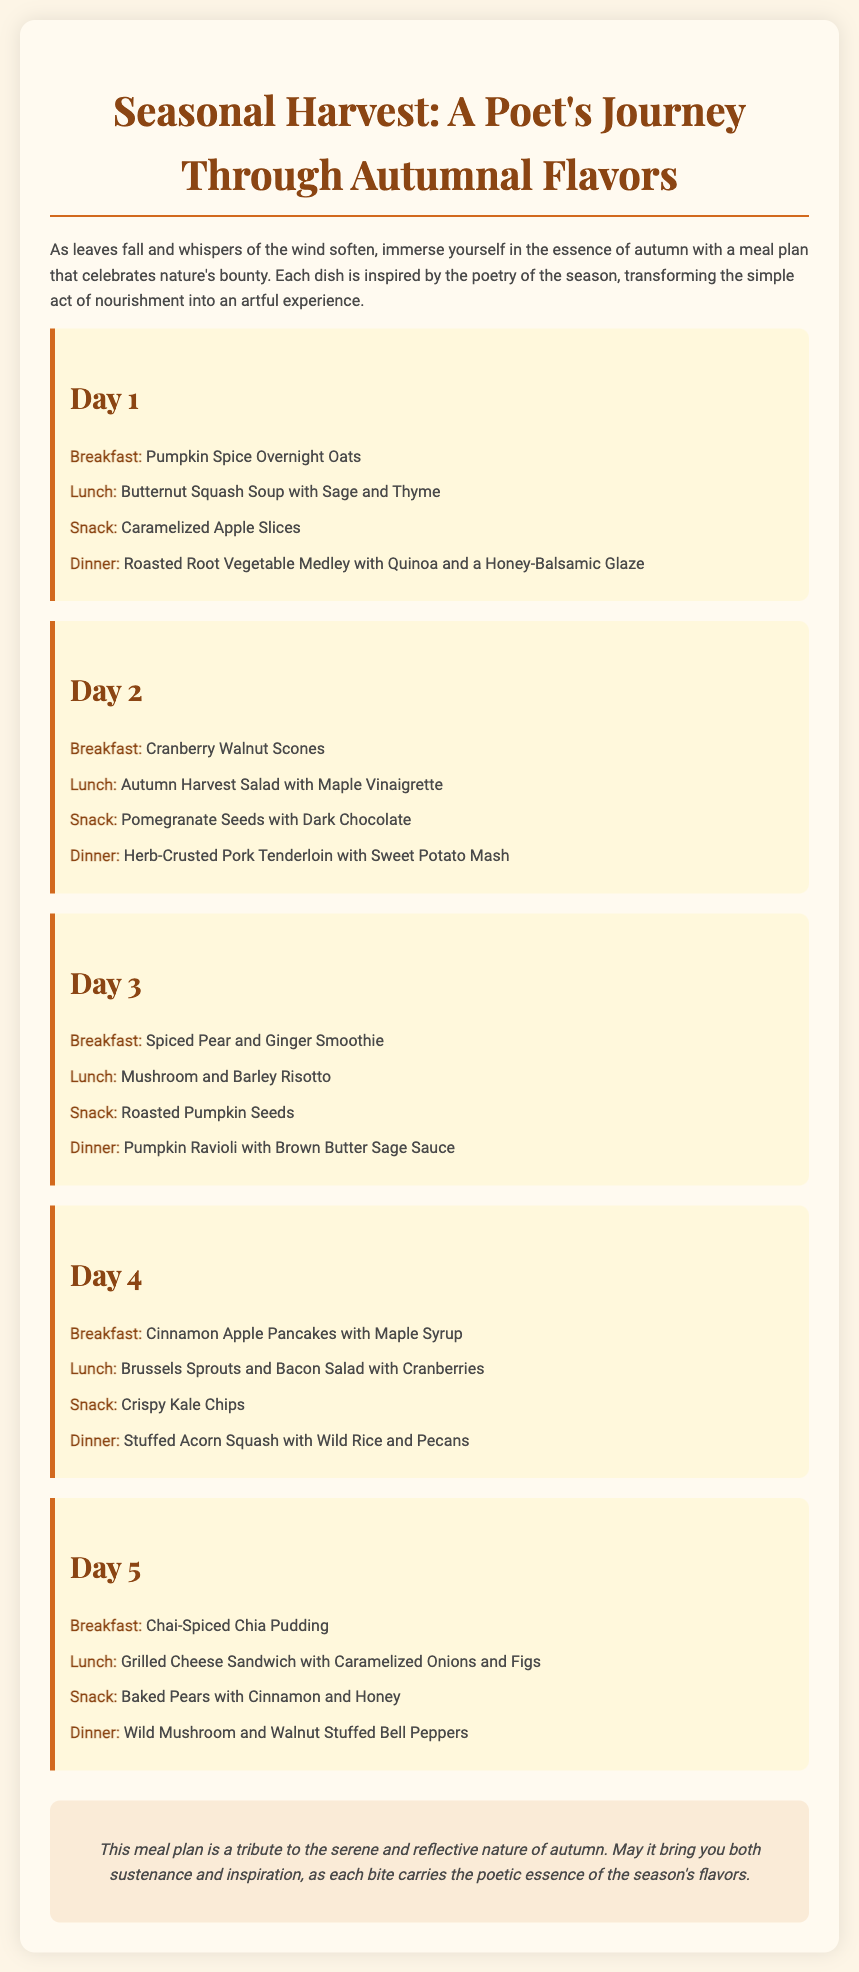What is the title of the meal plan? The title of the meal plan is presented prominently at the top of the document.
Answer: Seasonal Harvest: A Poet's Journey Through Autumnal Flavors What is the first breakfast on Day 1? The first breakfast is listed under Day 1 in the meal plan.
Answer: Pumpkin Spice Overnight Oats How many days does the meal plan cover? The document includes a specific number of days for the meal plan.
Answer: Five days What type of dish is served for dinner on Day 3? The dinner dish can be found within the Day 3 section of the meal plan.
Answer: Pumpkin Ravioli with Brown Butter Sage Sauce Which fruit is featured in the snack for Day 5? The snack for Day 5 mentions a specific fruit.
Answer: Pear What common flavor is present in the breakfast for Day 4? The breakfast dish on Day 4 prominently includes a specific flavor.
Answer: Cinnamon What is the overall theme of the meal plan? The document illustrates a central theme that encapsulates the meal choices.
Answer: Autumnal Flavors Which salad is served for lunch on Day 2? The lunch for Day 2 specifies a particular salad.
Answer: Autumn Harvest Salad with Maple Vinaigrette 